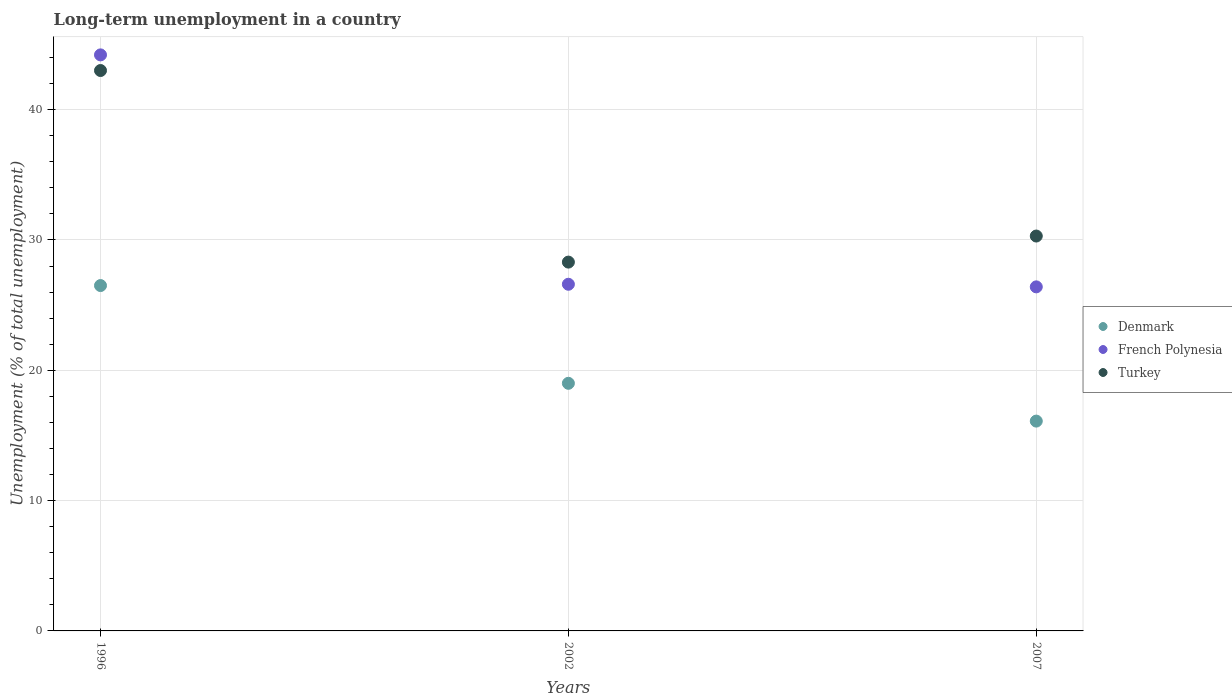Is the number of dotlines equal to the number of legend labels?
Provide a succinct answer. Yes. What is the percentage of long-term unemployed population in French Polynesia in 1996?
Provide a succinct answer. 44.2. Across all years, what is the minimum percentage of long-term unemployed population in Denmark?
Ensure brevity in your answer.  16.1. In which year was the percentage of long-term unemployed population in Denmark maximum?
Offer a very short reply. 1996. In which year was the percentage of long-term unemployed population in Denmark minimum?
Provide a short and direct response. 2007. What is the total percentage of long-term unemployed population in Turkey in the graph?
Provide a succinct answer. 101.6. What is the difference between the percentage of long-term unemployed population in Turkey in 1996 and that in 2007?
Your response must be concise. 12.7. What is the difference between the percentage of long-term unemployed population in Turkey in 2002 and the percentage of long-term unemployed population in French Polynesia in 2007?
Offer a very short reply. 1.9. What is the average percentage of long-term unemployed population in Denmark per year?
Your answer should be very brief. 20.53. In how many years, is the percentage of long-term unemployed population in Denmark greater than 40 %?
Offer a very short reply. 0. What is the ratio of the percentage of long-term unemployed population in Turkey in 1996 to that in 2002?
Provide a short and direct response. 1.52. Is the percentage of long-term unemployed population in French Polynesia in 2002 less than that in 2007?
Your answer should be compact. No. Is the difference between the percentage of long-term unemployed population in Turkey in 1996 and 2007 greater than the difference between the percentage of long-term unemployed population in Denmark in 1996 and 2007?
Provide a succinct answer. Yes. What is the difference between the highest and the lowest percentage of long-term unemployed population in Turkey?
Ensure brevity in your answer.  14.7. In how many years, is the percentage of long-term unemployed population in Turkey greater than the average percentage of long-term unemployed population in Turkey taken over all years?
Make the answer very short. 1. Is the sum of the percentage of long-term unemployed population in Denmark in 1996 and 2002 greater than the maximum percentage of long-term unemployed population in Turkey across all years?
Provide a succinct answer. Yes. Is it the case that in every year, the sum of the percentage of long-term unemployed population in French Polynesia and percentage of long-term unemployed population in Denmark  is greater than the percentage of long-term unemployed population in Turkey?
Keep it short and to the point. Yes. Is the percentage of long-term unemployed population in French Polynesia strictly greater than the percentage of long-term unemployed population in Turkey over the years?
Give a very brief answer. No. How many years are there in the graph?
Offer a very short reply. 3. Are the values on the major ticks of Y-axis written in scientific E-notation?
Make the answer very short. No. Does the graph contain any zero values?
Offer a terse response. No. Does the graph contain grids?
Make the answer very short. Yes. How many legend labels are there?
Provide a short and direct response. 3. How are the legend labels stacked?
Provide a short and direct response. Vertical. What is the title of the graph?
Your response must be concise. Long-term unemployment in a country. Does "Cayman Islands" appear as one of the legend labels in the graph?
Give a very brief answer. No. What is the label or title of the X-axis?
Your response must be concise. Years. What is the label or title of the Y-axis?
Your answer should be compact. Unemployment (% of total unemployment). What is the Unemployment (% of total unemployment) of Denmark in 1996?
Ensure brevity in your answer.  26.5. What is the Unemployment (% of total unemployment) in French Polynesia in 1996?
Your answer should be very brief. 44.2. What is the Unemployment (% of total unemployment) of French Polynesia in 2002?
Provide a short and direct response. 26.6. What is the Unemployment (% of total unemployment) in Turkey in 2002?
Provide a short and direct response. 28.3. What is the Unemployment (% of total unemployment) in Denmark in 2007?
Ensure brevity in your answer.  16.1. What is the Unemployment (% of total unemployment) of French Polynesia in 2007?
Offer a terse response. 26.4. What is the Unemployment (% of total unemployment) of Turkey in 2007?
Provide a succinct answer. 30.3. Across all years, what is the maximum Unemployment (% of total unemployment) of Denmark?
Ensure brevity in your answer.  26.5. Across all years, what is the maximum Unemployment (% of total unemployment) in French Polynesia?
Offer a terse response. 44.2. Across all years, what is the minimum Unemployment (% of total unemployment) in Denmark?
Your answer should be very brief. 16.1. Across all years, what is the minimum Unemployment (% of total unemployment) in French Polynesia?
Offer a terse response. 26.4. Across all years, what is the minimum Unemployment (% of total unemployment) of Turkey?
Keep it short and to the point. 28.3. What is the total Unemployment (% of total unemployment) in Denmark in the graph?
Your answer should be compact. 61.6. What is the total Unemployment (% of total unemployment) of French Polynesia in the graph?
Your answer should be compact. 97.2. What is the total Unemployment (% of total unemployment) of Turkey in the graph?
Make the answer very short. 101.6. What is the difference between the Unemployment (% of total unemployment) in French Polynesia in 1996 and that in 2002?
Give a very brief answer. 17.6. What is the difference between the Unemployment (% of total unemployment) in Denmark in 2002 and that in 2007?
Your answer should be very brief. 2.9. What is the difference between the Unemployment (% of total unemployment) of French Polynesia in 1996 and the Unemployment (% of total unemployment) of Turkey in 2002?
Provide a short and direct response. 15.9. What is the difference between the Unemployment (% of total unemployment) in Denmark in 2002 and the Unemployment (% of total unemployment) in French Polynesia in 2007?
Provide a succinct answer. -7.4. What is the average Unemployment (% of total unemployment) of Denmark per year?
Your response must be concise. 20.53. What is the average Unemployment (% of total unemployment) of French Polynesia per year?
Ensure brevity in your answer.  32.4. What is the average Unemployment (% of total unemployment) in Turkey per year?
Give a very brief answer. 33.87. In the year 1996, what is the difference between the Unemployment (% of total unemployment) in Denmark and Unemployment (% of total unemployment) in French Polynesia?
Offer a very short reply. -17.7. In the year 1996, what is the difference between the Unemployment (% of total unemployment) in Denmark and Unemployment (% of total unemployment) in Turkey?
Your response must be concise. -16.5. In the year 2002, what is the difference between the Unemployment (% of total unemployment) of Denmark and Unemployment (% of total unemployment) of Turkey?
Offer a very short reply. -9.3. In the year 2007, what is the difference between the Unemployment (% of total unemployment) in Denmark and Unemployment (% of total unemployment) in Turkey?
Give a very brief answer. -14.2. What is the ratio of the Unemployment (% of total unemployment) of Denmark in 1996 to that in 2002?
Ensure brevity in your answer.  1.39. What is the ratio of the Unemployment (% of total unemployment) in French Polynesia in 1996 to that in 2002?
Keep it short and to the point. 1.66. What is the ratio of the Unemployment (% of total unemployment) of Turkey in 1996 to that in 2002?
Offer a very short reply. 1.52. What is the ratio of the Unemployment (% of total unemployment) of Denmark in 1996 to that in 2007?
Give a very brief answer. 1.65. What is the ratio of the Unemployment (% of total unemployment) of French Polynesia in 1996 to that in 2007?
Keep it short and to the point. 1.67. What is the ratio of the Unemployment (% of total unemployment) of Turkey in 1996 to that in 2007?
Keep it short and to the point. 1.42. What is the ratio of the Unemployment (% of total unemployment) of Denmark in 2002 to that in 2007?
Make the answer very short. 1.18. What is the ratio of the Unemployment (% of total unemployment) of French Polynesia in 2002 to that in 2007?
Your response must be concise. 1.01. What is the ratio of the Unemployment (% of total unemployment) in Turkey in 2002 to that in 2007?
Your answer should be compact. 0.93. What is the difference between the highest and the second highest Unemployment (% of total unemployment) in Denmark?
Offer a very short reply. 7.5. What is the difference between the highest and the lowest Unemployment (% of total unemployment) of Turkey?
Your response must be concise. 14.7. 